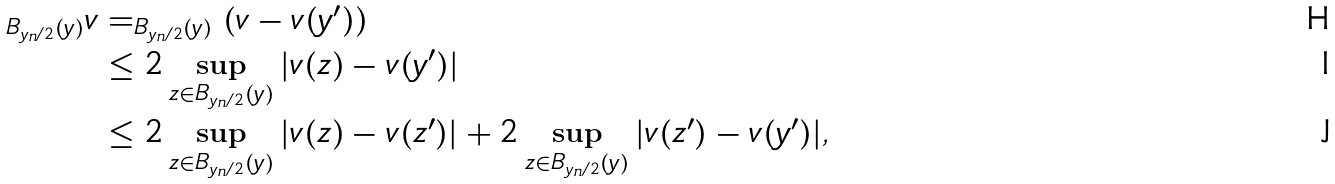Convert formula to latex. <formula><loc_0><loc_0><loc_500><loc_500>_ { B _ { y _ { n } / 2 } ( y ) } v & = _ { B _ { y _ { n } / 2 } ( y ) } \left ( v - v ( y ^ { \prime } ) \right ) \\ & \leq 2 \sup _ { z \in B _ { y _ { n } / 2 } ( y ) } | v ( z ) - v ( y ^ { \prime } ) | \\ & \leq 2 \sup _ { z \in B _ { y _ { n } / 2 } ( y ) } | v ( z ) - v ( z ^ { \prime } ) | + 2 \sup _ { z \in B _ { y _ { n } / 2 } ( y ) } | v ( z ^ { \prime } ) - v ( y ^ { \prime } ) | ,</formula> 